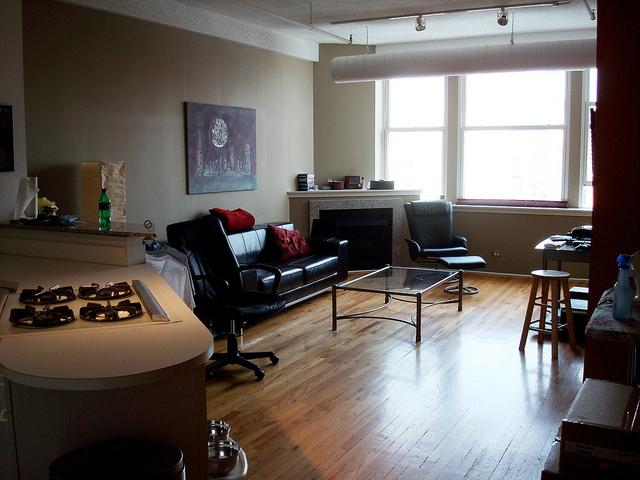How many framed objects?
Short answer required. 1. Is this an apartment?
Keep it brief. Yes. How many pictures are on the wall?
Give a very brief answer. 1. What room is photographed of the home?
Keep it brief. Living room. 